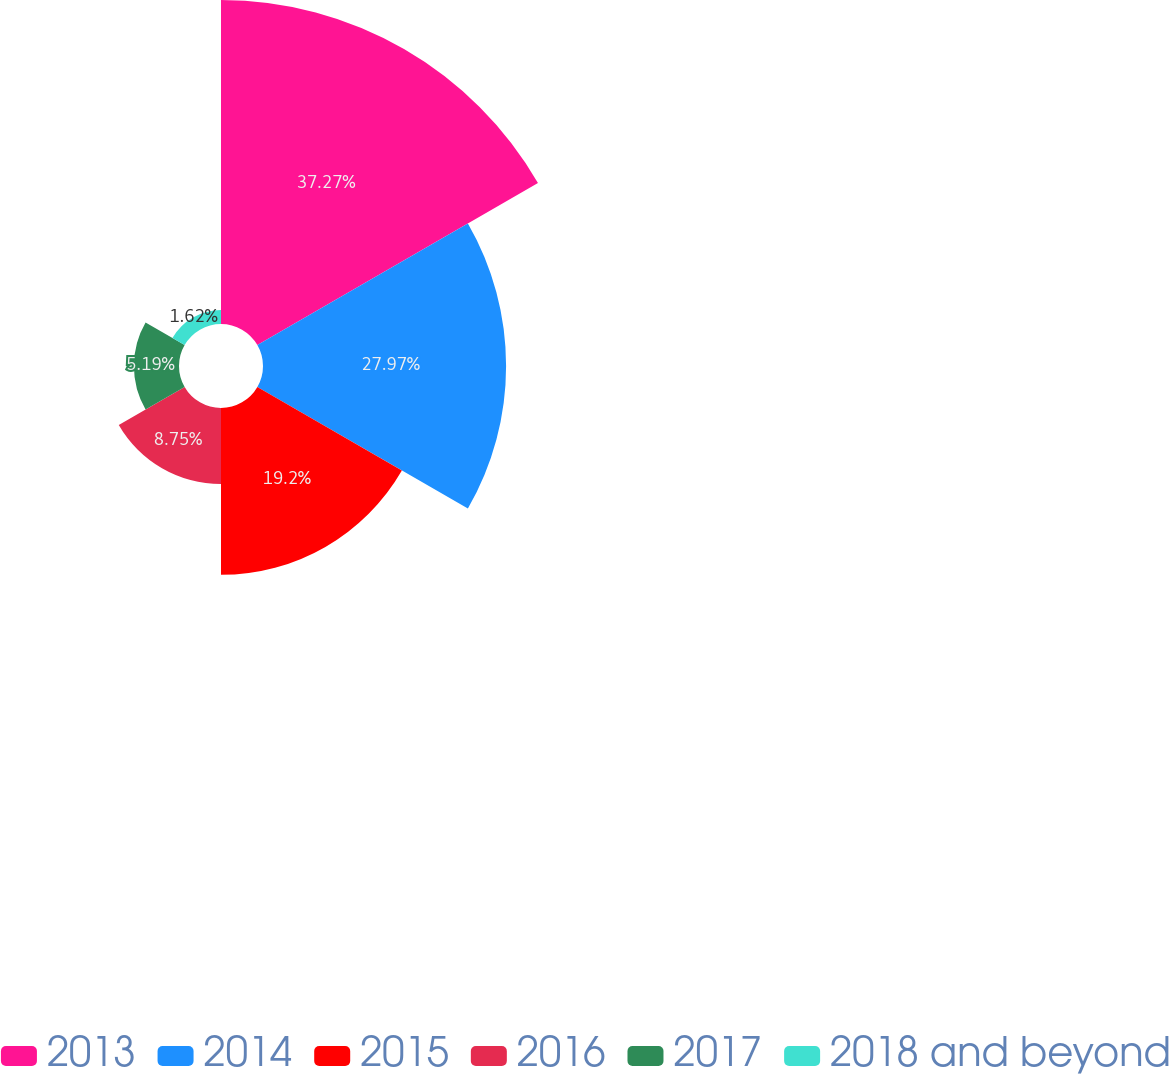<chart> <loc_0><loc_0><loc_500><loc_500><pie_chart><fcel>2013<fcel>2014<fcel>2015<fcel>2016<fcel>2017<fcel>2018 and beyond<nl><fcel>37.28%<fcel>27.97%<fcel>19.2%<fcel>8.75%<fcel>5.19%<fcel>1.62%<nl></chart> 